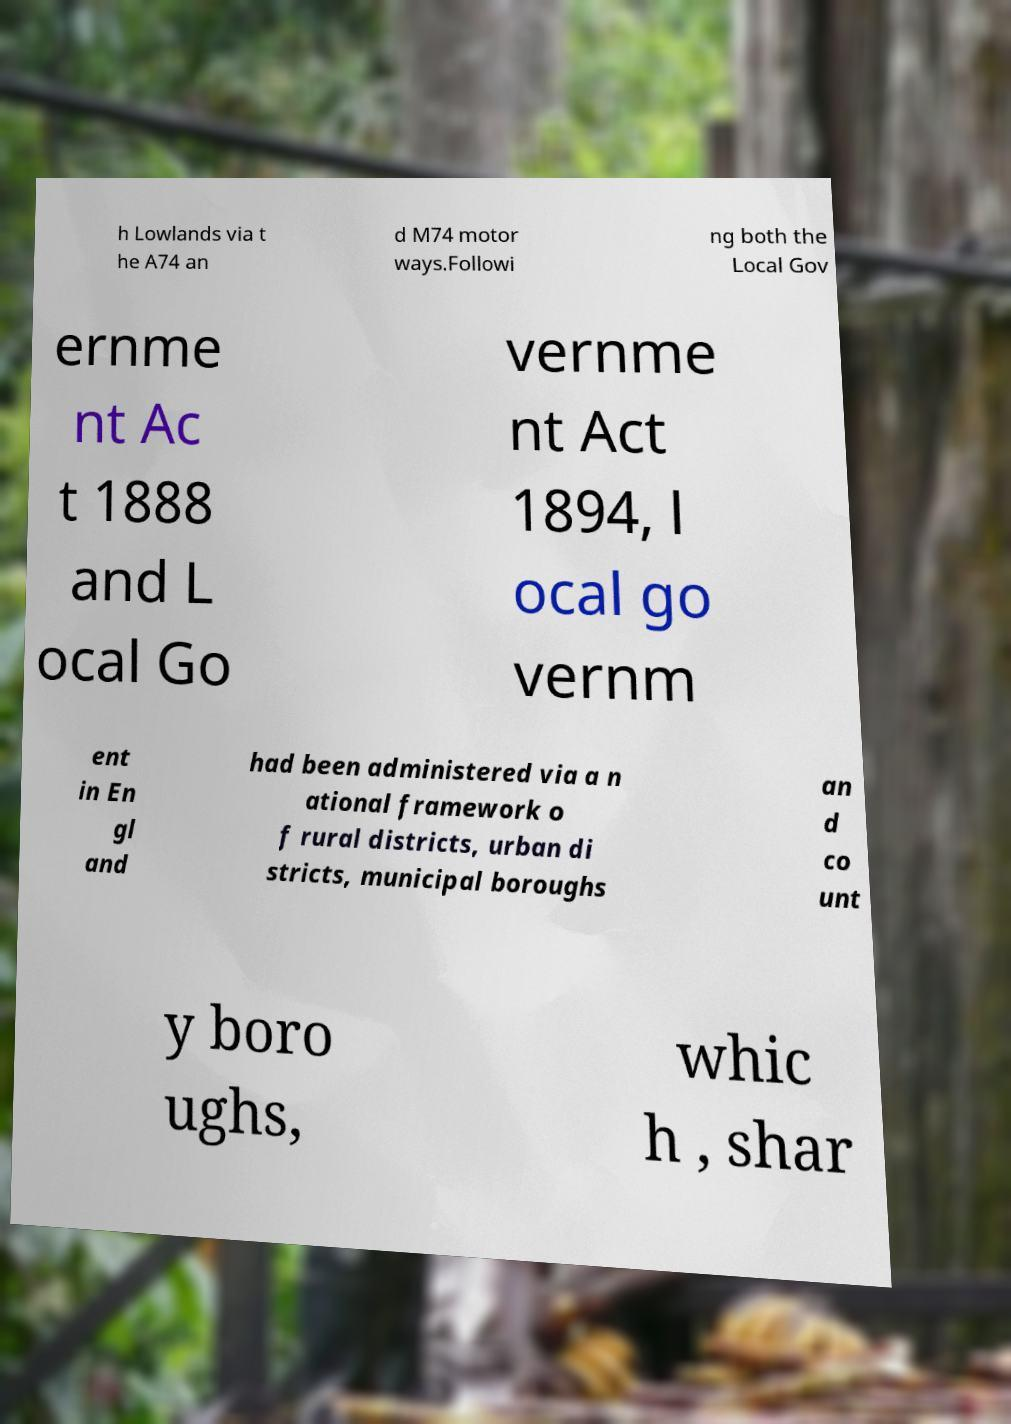Could you extract and type out the text from this image? h Lowlands via t he A74 an d M74 motor ways.Followi ng both the Local Gov ernme nt Ac t 1888 and L ocal Go vernme nt Act 1894, l ocal go vernm ent in En gl and had been administered via a n ational framework o f rural districts, urban di stricts, municipal boroughs an d co unt y boro ughs, whic h , shar 